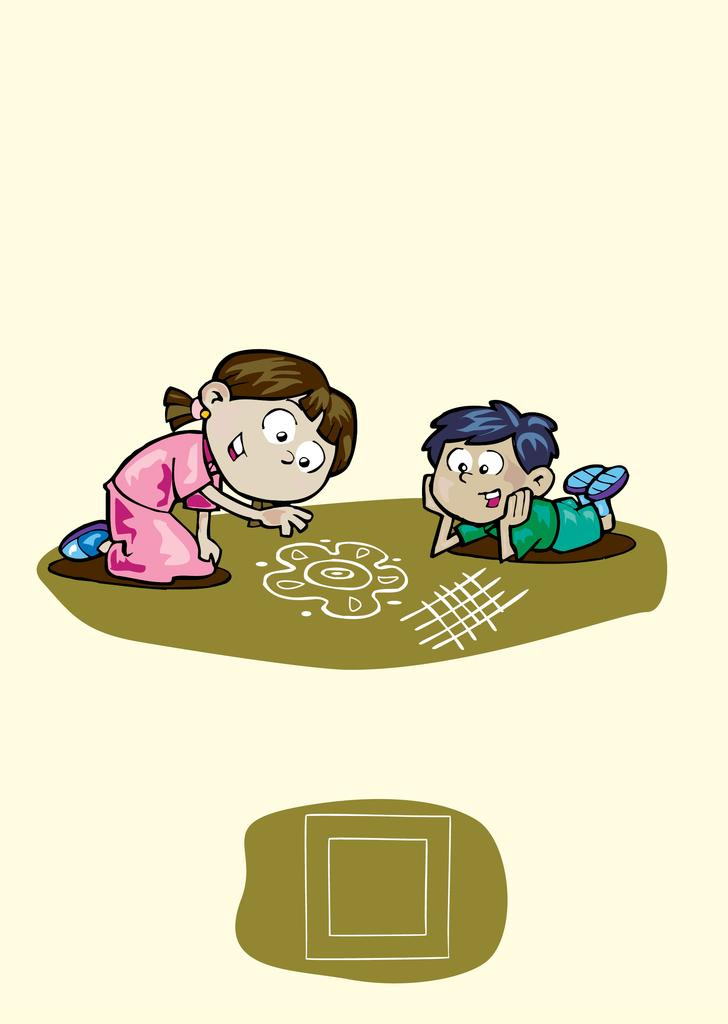What type of picture is the image? The image is an animated picture. Can you describe the girl in the image? The girl in the image is wearing a pink dress. What is the boy in the image doing? The boy is lying down. What is the decorative pattern in the image? There is a rangoli in the image. What is the color of the surface on which the rangoli is placed? The rangoli is on a brown surface. How many cakes are being washed in the image? There are no cakes present in the image, and therefore no washing activity can be observed. 